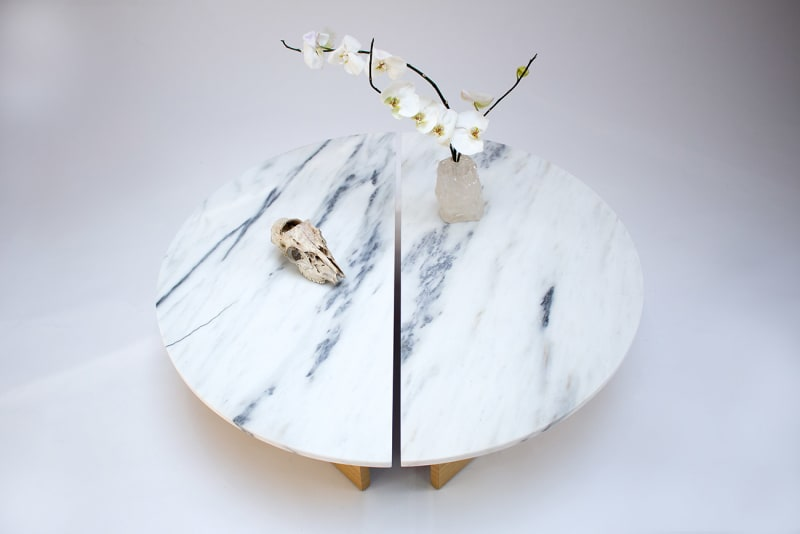Could there be a specific cultural or historical significance to this arrangement? Such a tableau might not be directly rooted in a specific cultural or historical tradition but rather taps into a universal human fascination with the juxtaposition of life and death, permanence and decay. These concepts have been explored in art and philosophy across cultures and eras. The elements chosen could be seen as a modern interpretation of a 'vanitas' still life, a genre which includes symbols like flowers and skulls to remind viewers of life's transience and the importance of living with awareness of its fleeting nature. 